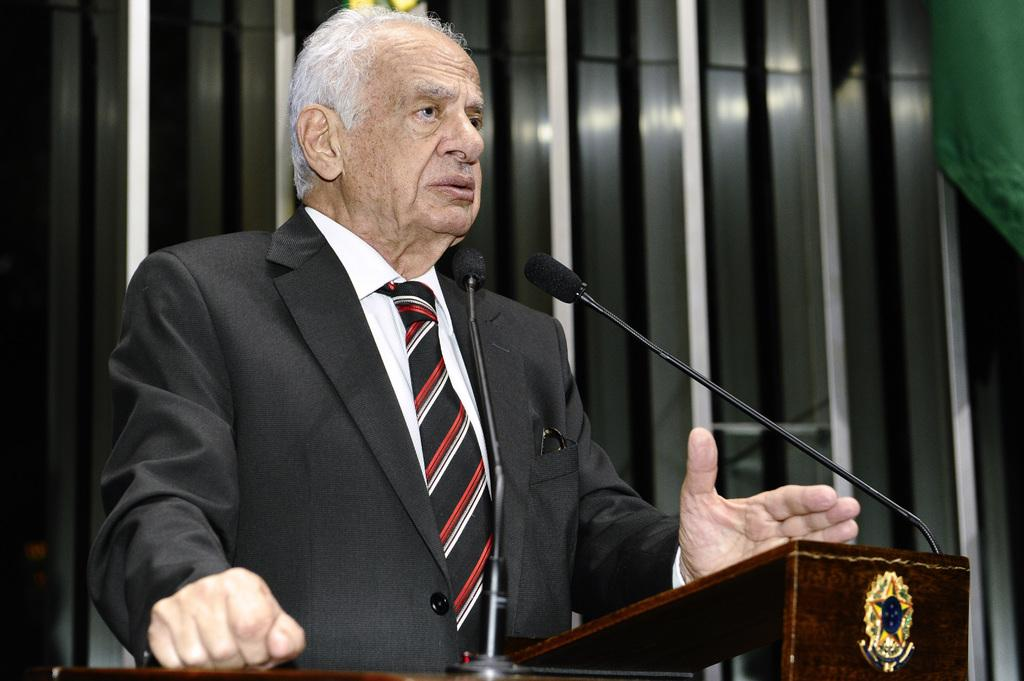Who is the main subject in the image? There is a man in the image. What is the man standing in front of? There is a podium in front of the man. What is used for amplifying sound in the image? There are microphones on or near the podium. What can be seen in the background of the image? There are objects visible in the background of the image. What type of blade is being used by the robin in the image? There is no robin or blade present in the image. What direction is the current flowing in the image? There is no reference to a current or any flowing water in the image. 